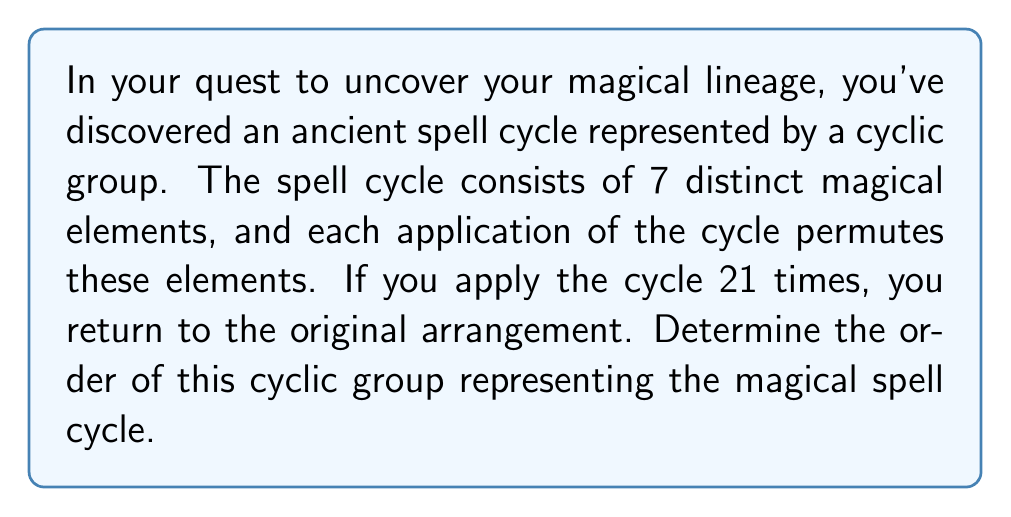Can you solve this math problem? Let's approach this step-by-step:

1) In group theory, a cyclic group is a group that can be generated by a single element. The order of a cyclic group is the smallest positive integer $n$ such that $a^n = e$, where $a$ is the generator and $e$ is the identity element.

2) In this case, we're told that applying the cycle 21 times returns us to the original arrangement. This means that 21 is a multiple of the order of the group. However, it may not be the smallest such number.

3) We're also told that the cycle consists of 7 distinct magical elements. This is a crucial piece of information.

4) In a cyclic permutation of $n$ distinct elements, the order of the permutation is always $n$. This is because it takes exactly $n$ applications of the permutation to return each element to its original position.

5) Therefore, the order of this cyclic group is 7.

6) We can verify this:
   $7 \mid 21$ (7 divides 21)
   $21 = 7 \times 3$

7) This means that after 7 applications of the cycle, we return to the original arrangement, and 21 applications is equivalent to 3 full cycles.
Answer: The order of the cyclic group representing the magical spell cycle is 7. 